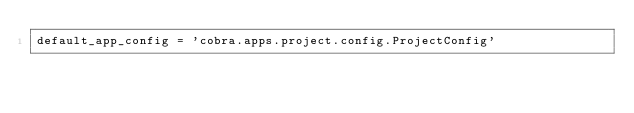Convert code to text. <code><loc_0><loc_0><loc_500><loc_500><_Python_>default_app_config = 'cobra.apps.project.config.ProjectConfig'
</code> 